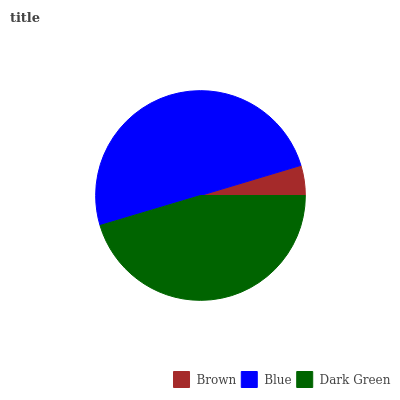Is Brown the minimum?
Answer yes or no. Yes. Is Blue the maximum?
Answer yes or no. Yes. Is Dark Green the minimum?
Answer yes or no. No. Is Dark Green the maximum?
Answer yes or no. No. Is Blue greater than Dark Green?
Answer yes or no. Yes. Is Dark Green less than Blue?
Answer yes or no. Yes. Is Dark Green greater than Blue?
Answer yes or no. No. Is Blue less than Dark Green?
Answer yes or no. No. Is Dark Green the high median?
Answer yes or no. Yes. Is Dark Green the low median?
Answer yes or no. Yes. Is Blue the high median?
Answer yes or no. No. Is Blue the low median?
Answer yes or no. No. 